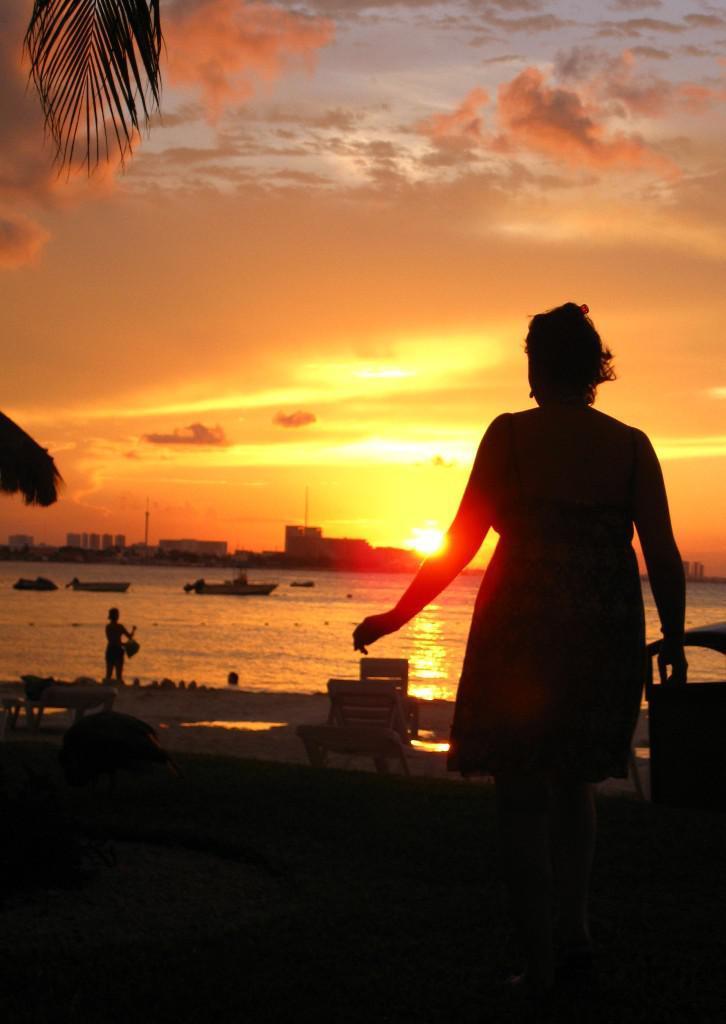In one or two sentences, can you explain what this image depicts? In this picture I can observe woman on the right side. There is a bench in the middle of the picture. I can observe a river. In the background there are buildings and some clouds in the sky. 